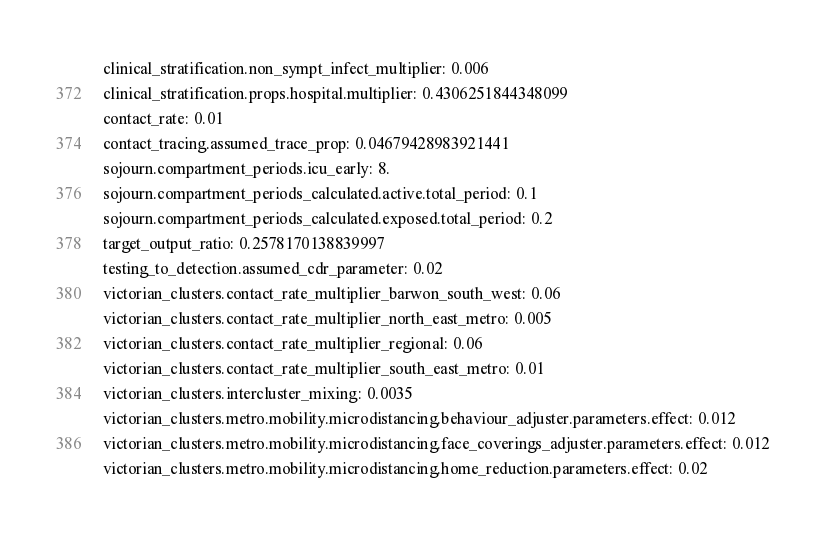<code> <loc_0><loc_0><loc_500><loc_500><_YAML_>clinical_stratification.non_sympt_infect_multiplier: 0.006
clinical_stratification.props.hospital.multiplier: 0.4306251844348099
contact_rate: 0.01
contact_tracing.assumed_trace_prop: 0.04679428983921441
sojourn.compartment_periods.icu_early: 8.
sojourn.compartment_periods_calculated.active.total_period: 0.1
sojourn.compartment_periods_calculated.exposed.total_period: 0.2
target_output_ratio: 0.2578170138839997
testing_to_detection.assumed_cdr_parameter: 0.02
victorian_clusters.contact_rate_multiplier_barwon_south_west: 0.06
victorian_clusters.contact_rate_multiplier_north_east_metro: 0.005
victorian_clusters.contact_rate_multiplier_regional: 0.06
victorian_clusters.contact_rate_multiplier_south_east_metro: 0.01
victorian_clusters.intercluster_mixing: 0.0035
victorian_clusters.metro.mobility.microdistancing.behaviour_adjuster.parameters.effect: 0.012
victorian_clusters.metro.mobility.microdistancing.face_coverings_adjuster.parameters.effect: 0.012
victorian_clusters.metro.mobility.microdistancing.home_reduction.parameters.effect: 0.02</code> 